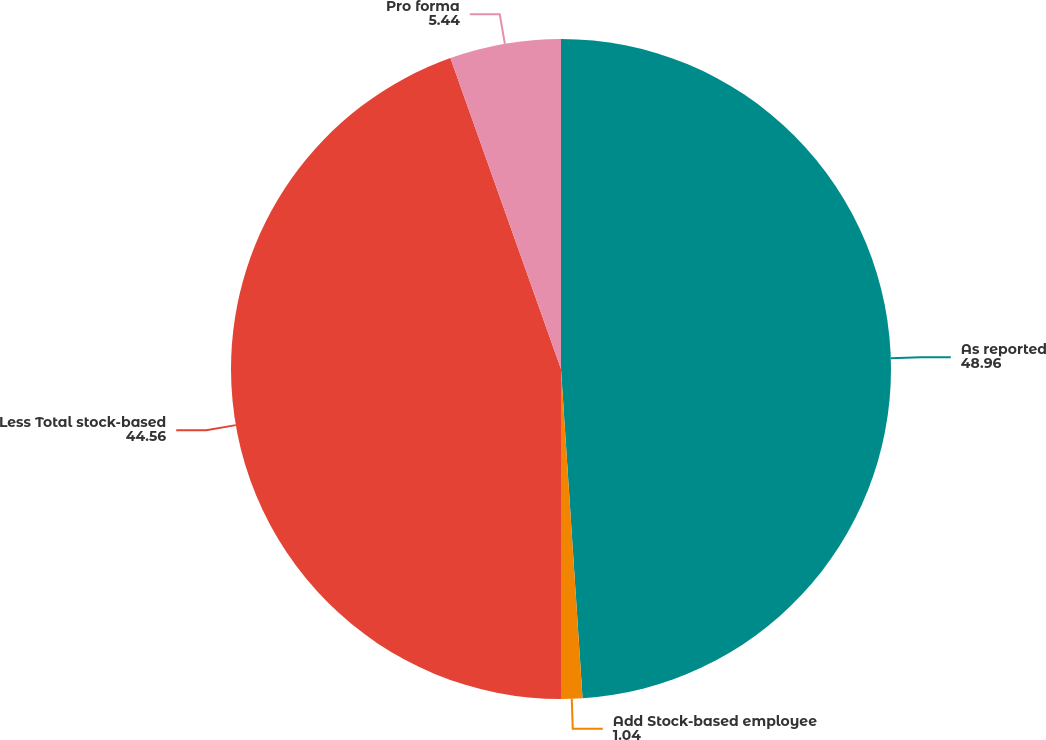Convert chart. <chart><loc_0><loc_0><loc_500><loc_500><pie_chart><fcel>As reported<fcel>Add Stock-based employee<fcel>Less Total stock-based<fcel>Pro forma<nl><fcel>48.96%<fcel>1.04%<fcel>44.56%<fcel>5.44%<nl></chart> 